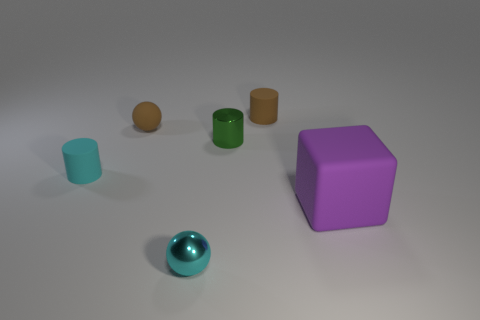There is a cyan metal ball that is right of the brown rubber thing that is to the left of the matte cylinder right of the cyan metallic ball; how big is it?
Provide a short and direct response. Small. What number of other objects are there of the same shape as the cyan shiny object?
Provide a succinct answer. 1. Is the color of the tiny rubber object right of the small cyan sphere the same as the metal object that is in front of the purple cube?
Ensure brevity in your answer.  No. What color is the other sphere that is the same size as the metallic ball?
Offer a terse response. Brown. Are there any small matte spheres that have the same color as the large rubber object?
Provide a succinct answer. No. There is a cylinder that is on the left side of the cyan shiny sphere; is its size the same as the large cube?
Provide a succinct answer. No. Are there the same number of purple objects that are left of the small brown rubber sphere and big rubber cubes?
Offer a very short reply. No. What number of things are either cyan things in front of the big purple object or gray cubes?
Your answer should be compact. 1. What shape is the object that is to the left of the small cyan shiny ball and behind the small cyan cylinder?
Provide a short and direct response. Sphere. What number of objects are small brown cylinders that are right of the tiny cyan rubber cylinder or small brown rubber objects that are on the right side of the green cylinder?
Offer a very short reply. 1. 